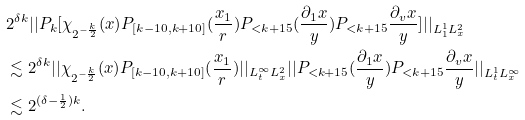<formula> <loc_0><loc_0><loc_500><loc_500>& 2 ^ { \delta k } | | P _ { k } [ \chi _ { 2 ^ { - \frac { k } { 2 } } } ( x ) P _ { [ k - 1 0 , k + 1 0 ] } ( \frac { x _ { 1 } } { r } ) P _ { < k + 1 5 } ( \frac { \partial _ { 1 } { x } } { y } ) P _ { < k + 1 5 } \frac { \partial _ { v } { x } } { y } ] | | _ { L _ { 1 } ^ { 1 } L _ { x } ^ { 2 } } \\ & \lesssim 2 ^ { \delta k } | | \chi _ { 2 ^ { - \frac { k } { 2 } } } ( x ) P _ { [ k - 1 0 , k + 1 0 ] } ( \frac { x _ { 1 } } { r } ) | | _ { L _ { t } ^ { \infty } L _ { x } ^ { 2 } } | | P _ { < k + 1 5 } ( \frac { \partial _ { 1 } { x } } { y } ) P _ { < k + 1 5 } \frac { \partial _ { v } { x } } { y } | | _ { L _ { t } ^ { 1 } L _ { x } ^ { \infty } } \\ & \lesssim 2 ^ { ( \delta - \frac { 1 } { 2 } ) k } . \\</formula> 